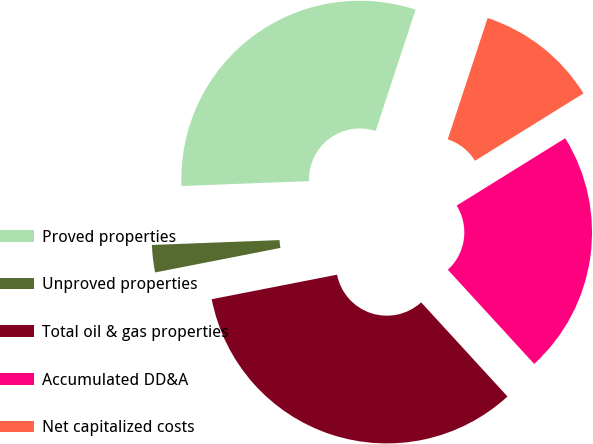<chart> <loc_0><loc_0><loc_500><loc_500><pie_chart><fcel>Proved properties<fcel>Unproved properties<fcel>Total oil & gas properties<fcel>Accumulated DD&A<fcel>Net capitalized costs<nl><fcel>30.66%<fcel>2.47%<fcel>33.73%<fcel>22.03%<fcel>11.1%<nl></chart> 